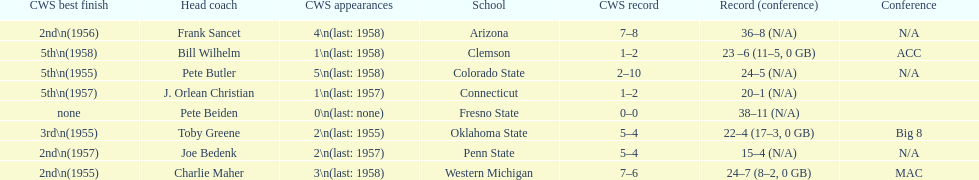Could you parse the entire table? {'header': ['CWS best finish', 'Head coach', 'CWS appearances', 'School', 'CWS record', 'Record (conference)', 'Conference'], 'rows': [['2nd\\n(1956)', 'Frank Sancet', '4\\n(last: 1958)', 'Arizona', '7–8', '36–8 (N/A)', 'N/A'], ['5th\\n(1958)', 'Bill Wilhelm', '1\\n(last: 1958)', 'Clemson', '1–2', '23 –6 (11–5, 0 GB)', 'ACC'], ['5th\\n(1955)', 'Pete Butler', '5\\n(last: 1958)', 'Colorado State', '2–10', '24–5 (N/A)', 'N/A'], ['5th\\n(1957)', 'J. Orlean Christian', '1\\n(last: 1957)', 'Connecticut', '1–2', '20–1 (N/A)', ''], ['none', 'Pete Beiden', '0\\n(last: none)', 'Fresno State', '0–0', '38–11 (N/A)', ''], ['3rd\\n(1955)', 'Toby Greene', '2\\n(last: 1955)', 'Oklahoma State', '5–4', '22–4 (17–3, 0 GB)', 'Big 8'], ['2nd\\n(1957)', 'Joe Bedenk', '2\\n(last: 1957)', 'Penn State', '5–4', '15–4 (N/A)', 'N/A'], ['2nd\\n(1955)', 'Charlie Maher', '3\\n(last: 1958)', 'Western Michigan', '7–6', '24–7 (8–2, 0 GB)', 'MAC']]} List each of the schools that came in 2nd for cws best finish. Arizona, Penn State, Western Michigan. 